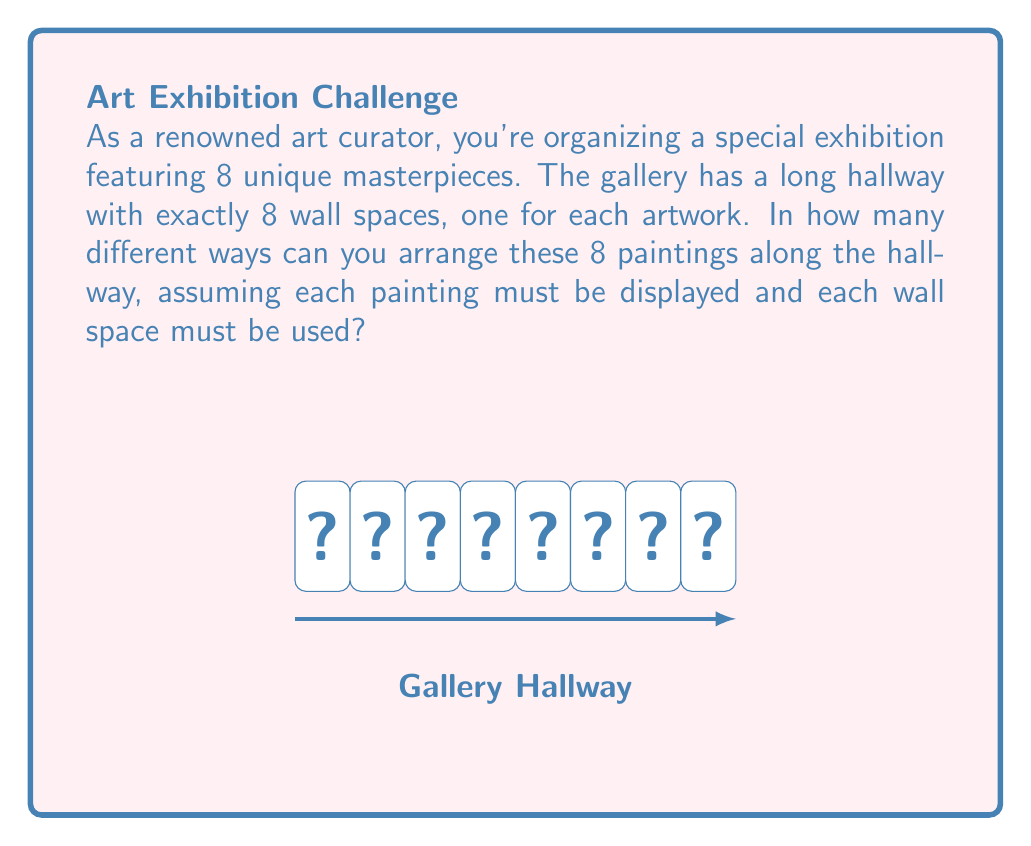Could you help me with this problem? Let's approach this step-by-step:

1) This problem is essentially asking about the number of permutations of 8 distinct objects (the artworks) in 8 positions (the wall spaces).

2) In permutation problems, the order matters. Each unique arrangement of the artworks is considered a different permutation.

3) For the first wall space, we have 8 choices of artworks to hang.

4) After placing the first artwork, we have 7 choices for the second wall space.

5) For the third wall space, we'll have 6 choices, and so on.

6) This continues until we place the last artwork, for which we'll have only 1 choice left.

7) According to the multiplication principle, we multiply these numbers together:

   $$8 \times 7 \times 6 \times 5 \times 4 \times 3 \times 2 \times 1$$

8) This is also known as 8 factorial, denoted as $8!$

9) Calculating this:
   $$8! = 8 \times 7 \times 6 \times 5 \times 4 \times 3 \times 2 \times 1 = 40,320$$

Therefore, there are 40,320 unique ways to arrange the 8 artworks in the gallery hallway.
Answer: $40,320$ 